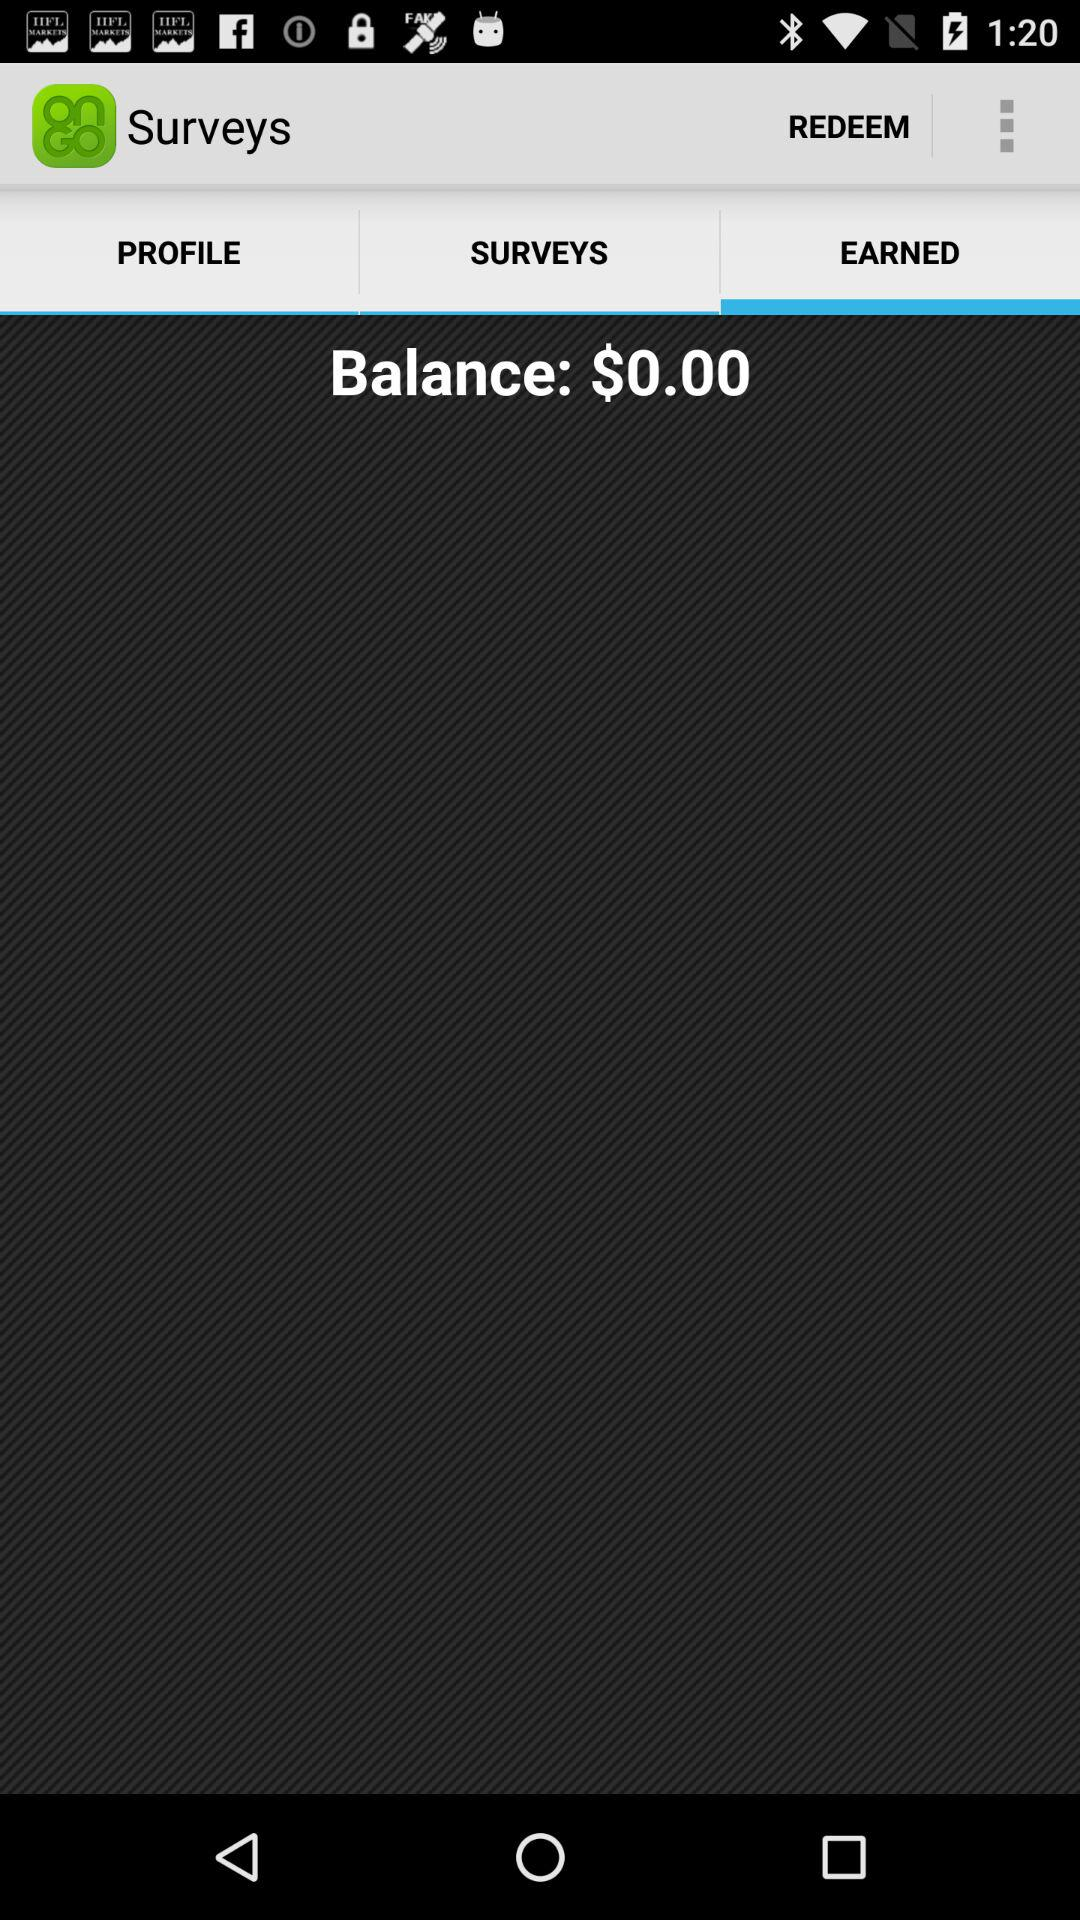How much money do I have in my balance?
Answer the question using a single word or phrase. $0.00 